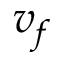Convert formula to latex. <formula><loc_0><loc_0><loc_500><loc_500>v _ { f }</formula> 